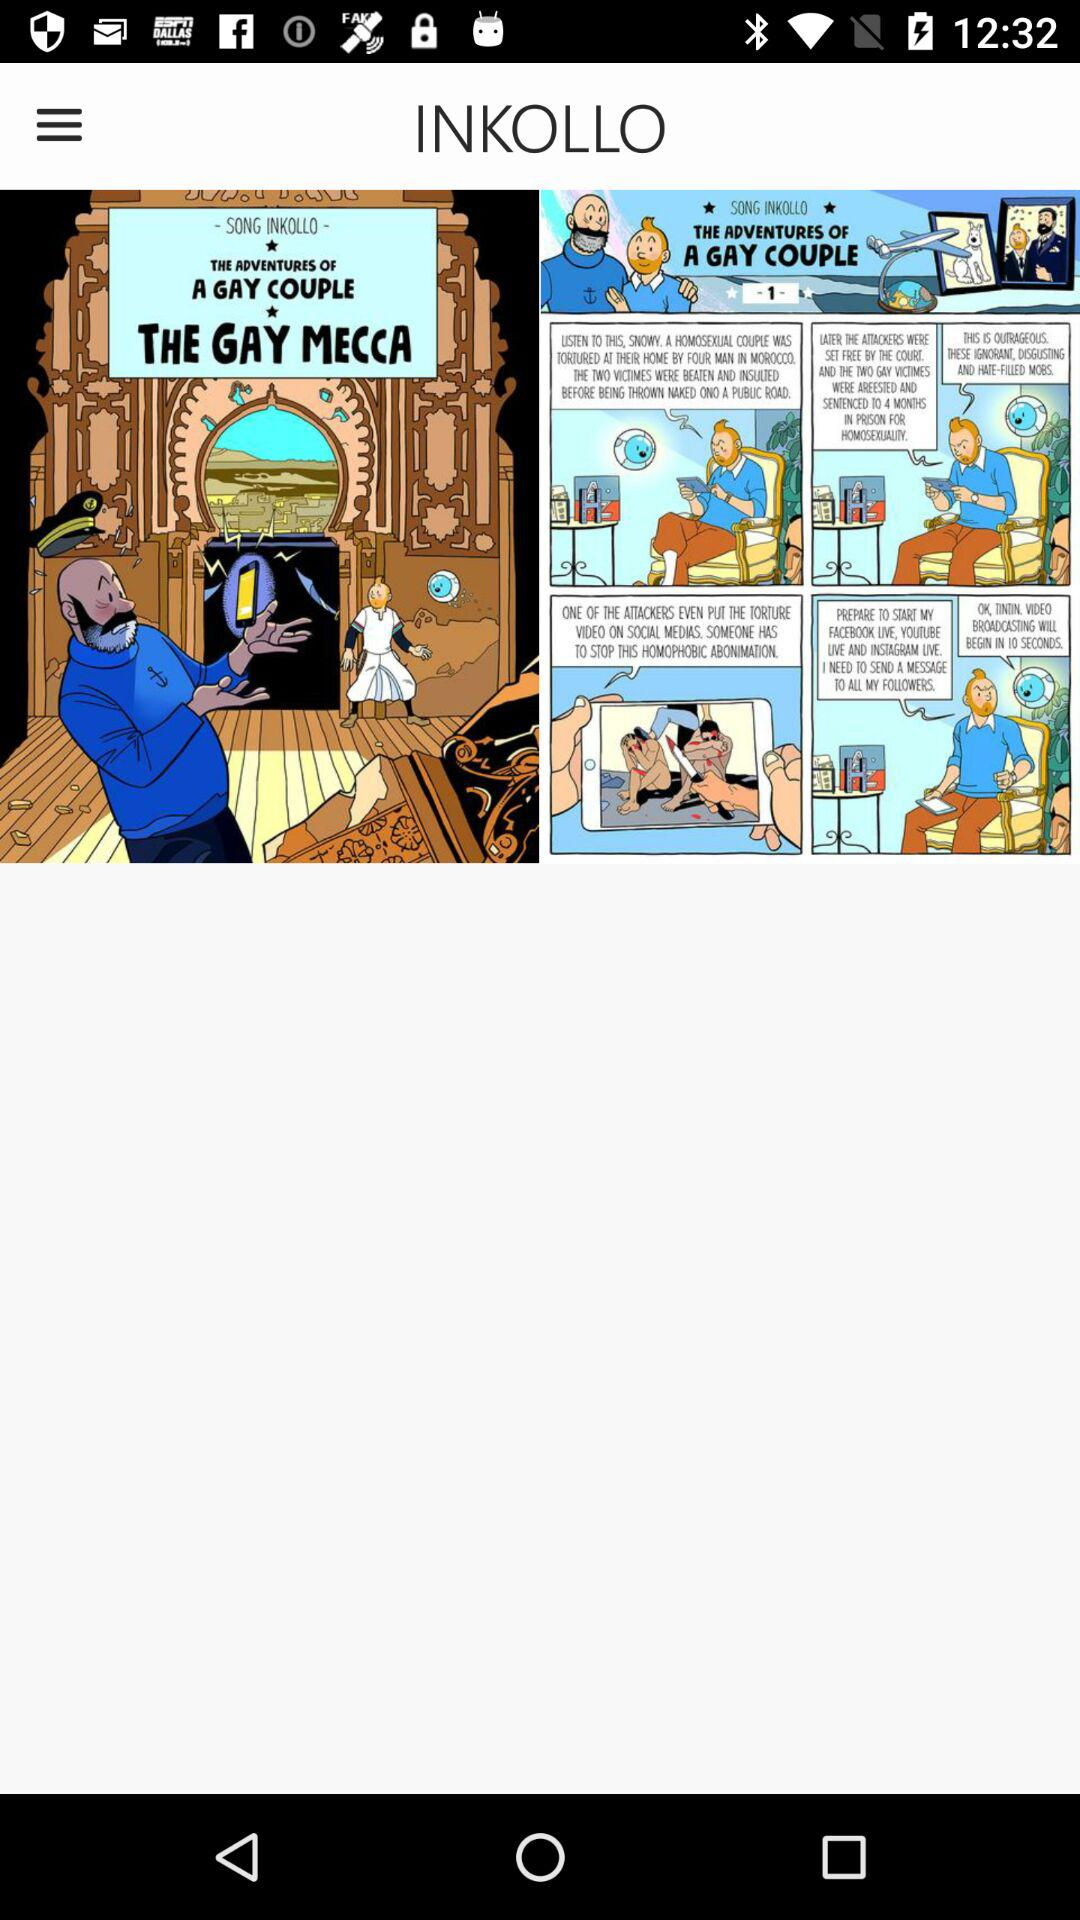What is the name of the application? The name of the application is "INKOLLO". 